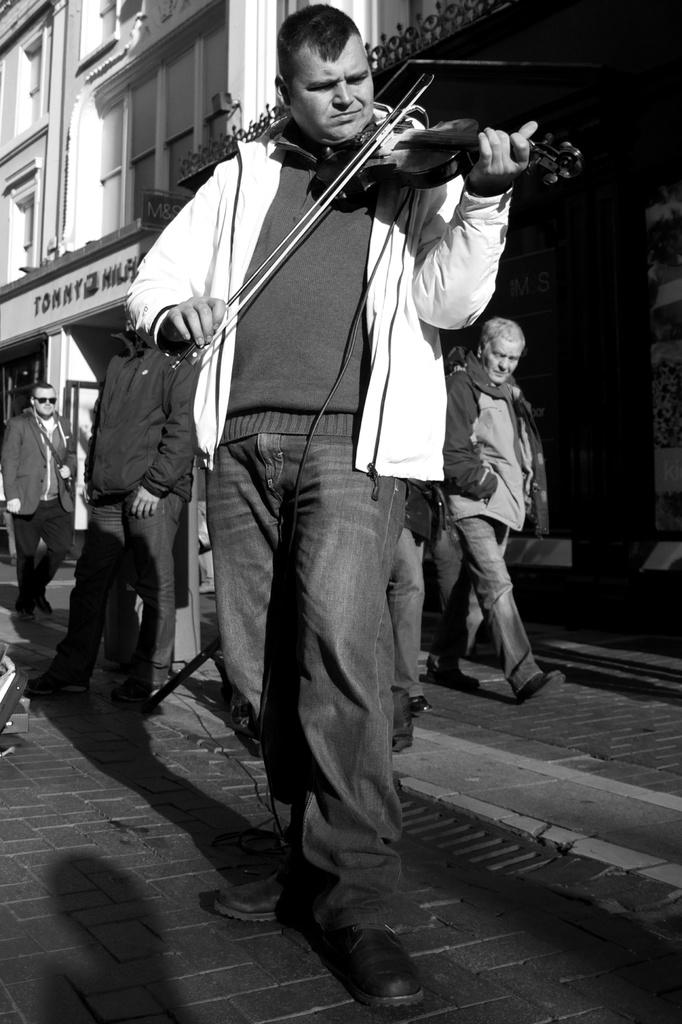Where was the image taken? The image was taken outside. What is the color scheme of the image? The image is in black and white. What is the main subject of the image? There is a person playing a violin in the image. What can be seen in the background of the image? There is a group of people and a building in the background of the image. Can you see any flies buzzing around the person playing the violin in the image? There are no flies visible in the image. Is there a straw sticking out of the violin in the image? There is no straw present in the image; it features a person playing a violin. 